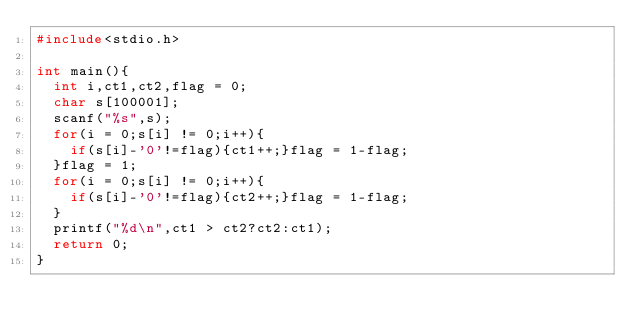Convert code to text. <code><loc_0><loc_0><loc_500><loc_500><_C_>#include<stdio.h>

int main(){
  int i,ct1,ct2,flag = 0;
  char s[100001];
  scanf("%s",s);
  for(i = 0;s[i] != 0;i++){
    if(s[i]-'0'!=flag){ct1++;}flag = 1-flag;
  }flag = 1;
  for(i = 0;s[i] != 0;i++){
    if(s[i]-'0'!=flag){ct2++;}flag = 1-flag;
  }
  printf("%d\n",ct1 > ct2?ct2:ct1);
  return 0;
}
</code> 